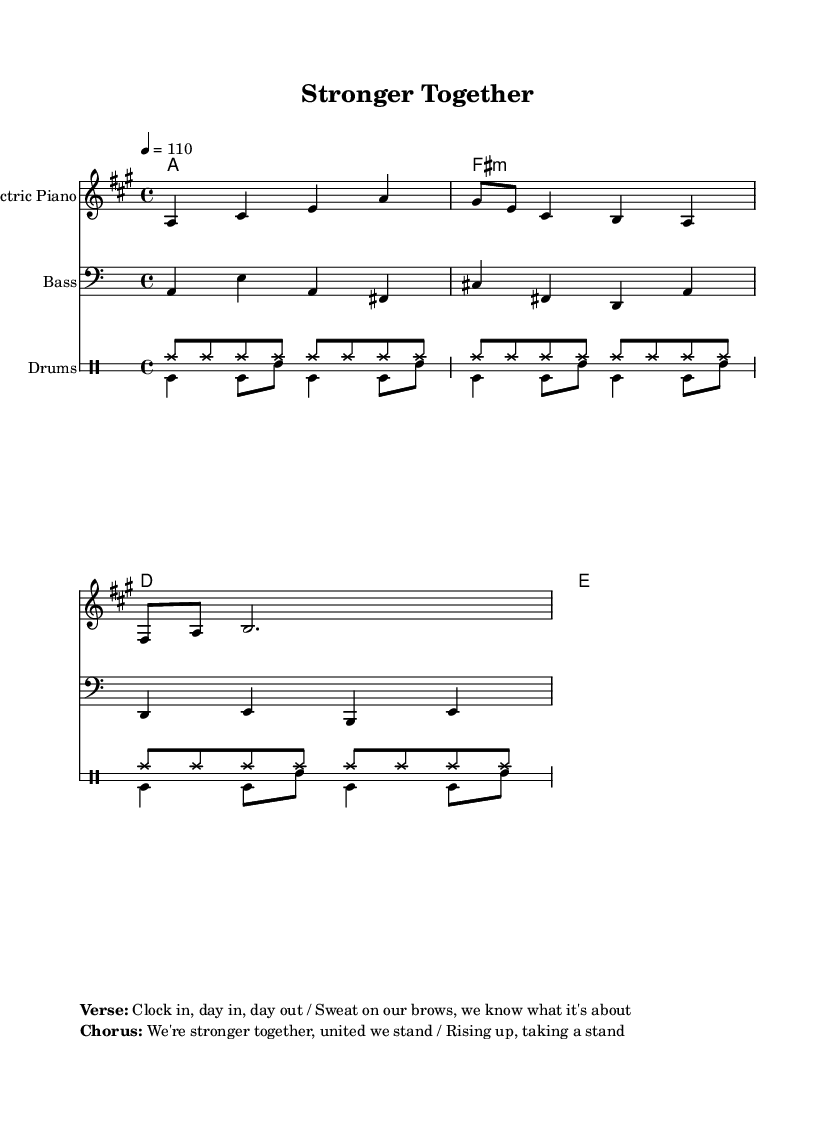What is the key signature of this music? The key signature is A major, which has three sharps (F#, C#, and G#). This can be identified in the opening of the staff where the key signature is indicated.
Answer: A major What is the time signature of this piece? The time signature is 4/4, seen at the beginning of the piece where the notation indicates that there are four beats in each measure.
Answer: 4/4 What is the tempo marking for this piece? The tempo is marked as quarter note equals 110 BPM, which is specified with the notation indicating the speed of the piece.
Answer: 110 What is the main theme of the chorus? The chorus emphasizes unity and resilience, with lyrics indicating "We're stronger together, united we stand." This can be found in the marked section of the lyrics provided.
Answer: Stronger together How many measures are in the melody section? The melody section consists of three measures, as can be counted in the given notation where the melody is written.
Answer: 3 What type of piano is indicated in the sheet music? The sheet music indicates "Electric Piano" as the instrument for the melody line, which is noted in the staff label.
Answer: Electric Piano What kind of drums are specified in the percussion section? The drum staff indicates the use of hi-hat and bass drum rhythms which are common in upbeat R&B tracks, based on the drumming patterns shown.
Answer: Hi-hat and bass drum 